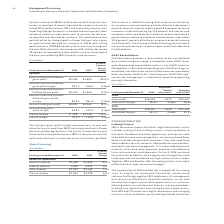According to International Business Machines's financial document, What led to decrease in Systems gross profit margin? The Systems gross profit margin decrease year to year was driven by the mix away from IBM Z and margin declines in Power Systems and Storage Systems.. The document states: "The Systems gross profit margin decrease year to year was driven by the mix away from IBM Z and margin declines in Power Systems and Storage Systems. ..." Also, What led to decrease in pre-tax income? The pre-tax income decline was driven by the strong performance in IBM Z in the prior year and the continued investment in innovation across the Systems portfolio.. The document states: "gin declines in Power Systems and Storage Systems. The pre-tax income decline was driven by the strong performance in IBM Z in the prior year and the ..." Also, Did the Systems gross profit margin increase or decrease year to year? The Systems gross profit margin decrease year to year. The document states: "The Systems gross profit margin decrease year to year was driven by the mix away from IBM Z and margin declines in Power Systems and Storage Systems. ..." Also, can you calculate: What is the average of External Systems Hardware gross profit? To answer this question, I need to perform calculations using the financial data. The calculation is: (2,590+2,893) / 2, which equals 2741.5 (in millions). This is based on the information: "External Systems Hardware gross profit $2,590 $2,893 (10.5)% External Systems Hardware gross profit $2,590 $2,893 (10.5)%..." The key data points involved are: 2,590, 2,893. Also, can you calculate: What is the increase/ (decrease) in External Systems Hardware gross profit from 2017 to 2018 Based on the calculation: 2,590-2,893, the result is -303 (in millions). This is based on the information: "External Systems Hardware gross profit $2,590 $2,893 (10.5)% External Systems Hardware gross profit $2,590 $2,893 (10.5)%..." The key data points involved are: 2,590, 2,893. Also, can you calculate: What is the increase/ (decrease) in Pre-tax margin from 2017 to 2018 Based on the calculation: 10.2-12.6 , the result is -2.4 (percentage). This is based on the information: "Pre-tax margin 10.2% 12.6% (2.4)pts. Pre-tax margin 10.2% 12.6% (2.4)pts...." The key data points involved are: 10.2, 12.6. 